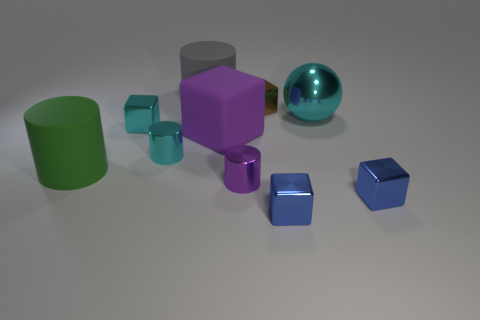Subtract all purple cylinders. How many cylinders are left? 3 Subtract 1 cylinders. How many cylinders are left? 3 Subtract all green cylinders. How many cylinders are left? 3 Subtract all gray cubes. Subtract all green cylinders. How many cubes are left? 5 Subtract all large green matte objects. Subtract all blue objects. How many objects are left? 7 Add 9 big purple rubber cubes. How many big purple rubber cubes are left? 10 Add 4 green matte things. How many green matte things exist? 5 Subtract 1 cyan balls. How many objects are left? 9 Subtract all cylinders. How many objects are left? 6 